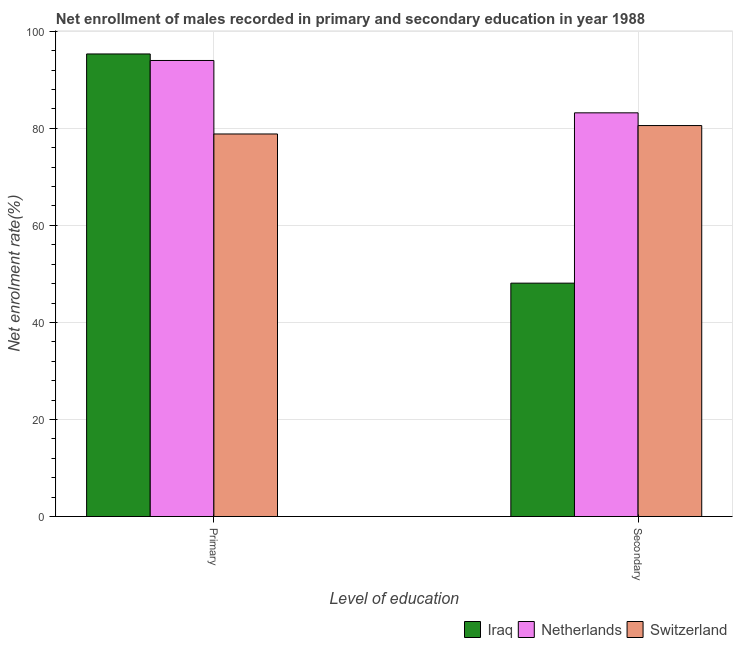How many different coloured bars are there?
Give a very brief answer. 3. How many bars are there on the 1st tick from the right?
Offer a very short reply. 3. What is the label of the 2nd group of bars from the left?
Make the answer very short. Secondary. What is the enrollment rate in secondary education in Switzerland?
Provide a succinct answer. 80.57. Across all countries, what is the maximum enrollment rate in primary education?
Your answer should be compact. 95.33. Across all countries, what is the minimum enrollment rate in secondary education?
Ensure brevity in your answer.  48.09. In which country was the enrollment rate in primary education maximum?
Provide a succinct answer. Iraq. In which country was the enrollment rate in secondary education minimum?
Give a very brief answer. Iraq. What is the total enrollment rate in secondary education in the graph?
Your answer should be compact. 211.86. What is the difference between the enrollment rate in primary education in Iraq and that in Switzerland?
Provide a succinct answer. 16.49. What is the difference between the enrollment rate in primary education in Switzerland and the enrollment rate in secondary education in Netherlands?
Give a very brief answer. -4.36. What is the average enrollment rate in secondary education per country?
Make the answer very short. 70.62. What is the difference between the enrollment rate in secondary education and enrollment rate in primary education in Switzerland?
Offer a terse response. 1.74. In how many countries, is the enrollment rate in primary education greater than 36 %?
Offer a very short reply. 3. What is the ratio of the enrollment rate in primary education in Netherlands to that in Switzerland?
Offer a very short reply. 1.19. Is the enrollment rate in secondary education in Netherlands less than that in Switzerland?
Provide a short and direct response. No. What does the 1st bar from the left in Secondary represents?
Your answer should be compact. Iraq. What does the 3rd bar from the right in Primary represents?
Give a very brief answer. Iraq. How many bars are there?
Give a very brief answer. 6. Are all the bars in the graph horizontal?
Keep it short and to the point. No. How many legend labels are there?
Provide a succinct answer. 3. What is the title of the graph?
Provide a short and direct response. Net enrollment of males recorded in primary and secondary education in year 1988. What is the label or title of the X-axis?
Ensure brevity in your answer.  Level of education. What is the label or title of the Y-axis?
Your answer should be compact. Net enrolment rate(%). What is the Net enrolment rate(%) of Iraq in Primary?
Offer a terse response. 95.33. What is the Net enrolment rate(%) of Netherlands in Primary?
Offer a very short reply. 93.98. What is the Net enrolment rate(%) of Switzerland in Primary?
Give a very brief answer. 78.84. What is the Net enrolment rate(%) in Iraq in Secondary?
Offer a terse response. 48.09. What is the Net enrolment rate(%) of Netherlands in Secondary?
Your response must be concise. 83.19. What is the Net enrolment rate(%) of Switzerland in Secondary?
Make the answer very short. 80.57. Across all Level of education, what is the maximum Net enrolment rate(%) of Iraq?
Your response must be concise. 95.33. Across all Level of education, what is the maximum Net enrolment rate(%) of Netherlands?
Keep it short and to the point. 93.98. Across all Level of education, what is the maximum Net enrolment rate(%) in Switzerland?
Provide a succinct answer. 80.57. Across all Level of education, what is the minimum Net enrolment rate(%) in Iraq?
Keep it short and to the point. 48.09. Across all Level of education, what is the minimum Net enrolment rate(%) in Netherlands?
Your answer should be very brief. 83.19. Across all Level of education, what is the minimum Net enrolment rate(%) of Switzerland?
Ensure brevity in your answer.  78.84. What is the total Net enrolment rate(%) of Iraq in the graph?
Offer a terse response. 143.42. What is the total Net enrolment rate(%) of Netherlands in the graph?
Provide a short and direct response. 177.17. What is the total Net enrolment rate(%) of Switzerland in the graph?
Give a very brief answer. 159.41. What is the difference between the Net enrolment rate(%) of Iraq in Primary and that in Secondary?
Provide a short and direct response. 47.23. What is the difference between the Net enrolment rate(%) of Netherlands in Primary and that in Secondary?
Ensure brevity in your answer.  10.79. What is the difference between the Net enrolment rate(%) in Switzerland in Primary and that in Secondary?
Give a very brief answer. -1.74. What is the difference between the Net enrolment rate(%) in Iraq in Primary and the Net enrolment rate(%) in Netherlands in Secondary?
Offer a terse response. 12.14. What is the difference between the Net enrolment rate(%) in Iraq in Primary and the Net enrolment rate(%) in Switzerland in Secondary?
Your answer should be compact. 14.75. What is the difference between the Net enrolment rate(%) of Netherlands in Primary and the Net enrolment rate(%) of Switzerland in Secondary?
Offer a very short reply. 13.41. What is the average Net enrolment rate(%) of Iraq per Level of education?
Give a very brief answer. 71.71. What is the average Net enrolment rate(%) in Netherlands per Level of education?
Ensure brevity in your answer.  88.59. What is the average Net enrolment rate(%) of Switzerland per Level of education?
Your answer should be very brief. 79.7. What is the difference between the Net enrolment rate(%) of Iraq and Net enrolment rate(%) of Netherlands in Primary?
Offer a very short reply. 1.34. What is the difference between the Net enrolment rate(%) of Iraq and Net enrolment rate(%) of Switzerland in Primary?
Your answer should be very brief. 16.49. What is the difference between the Net enrolment rate(%) in Netherlands and Net enrolment rate(%) in Switzerland in Primary?
Offer a terse response. 15.15. What is the difference between the Net enrolment rate(%) in Iraq and Net enrolment rate(%) in Netherlands in Secondary?
Ensure brevity in your answer.  -35.1. What is the difference between the Net enrolment rate(%) in Iraq and Net enrolment rate(%) in Switzerland in Secondary?
Provide a succinct answer. -32.48. What is the difference between the Net enrolment rate(%) of Netherlands and Net enrolment rate(%) of Switzerland in Secondary?
Your answer should be very brief. 2.62. What is the ratio of the Net enrolment rate(%) in Iraq in Primary to that in Secondary?
Your response must be concise. 1.98. What is the ratio of the Net enrolment rate(%) of Netherlands in Primary to that in Secondary?
Offer a terse response. 1.13. What is the ratio of the Net enrolment rate(%) of Switzerland in Primary to that in Secondary?
Your answer should be compact. 0.98. What is the difference between the highest and the second highest Net enrolment rate(%) in Iraq?
Make the answer very short. 47.23. What is the difference between the highest and the second highest Net enrolment rate(%) of Netherlands?
Your answer should be compact. 10.79. What is the difference between the highest and the second highest Net enrolment rate(%) in Switzerland?
Offer a terse response. 1.74. What is the difference between the highest and the lowest Net enrolment rate(%) in Iraq?
Offer a very short reply. 47.23. What is the difference between the highest and the lowest Net enrolment rate(%) of Netherlands?
Ensure brevity in your answer.  10.79. What is the difference between the highest and the lowest Net enrolment rate(%) in Switzerland?
Your response must be concise. 1.74. 